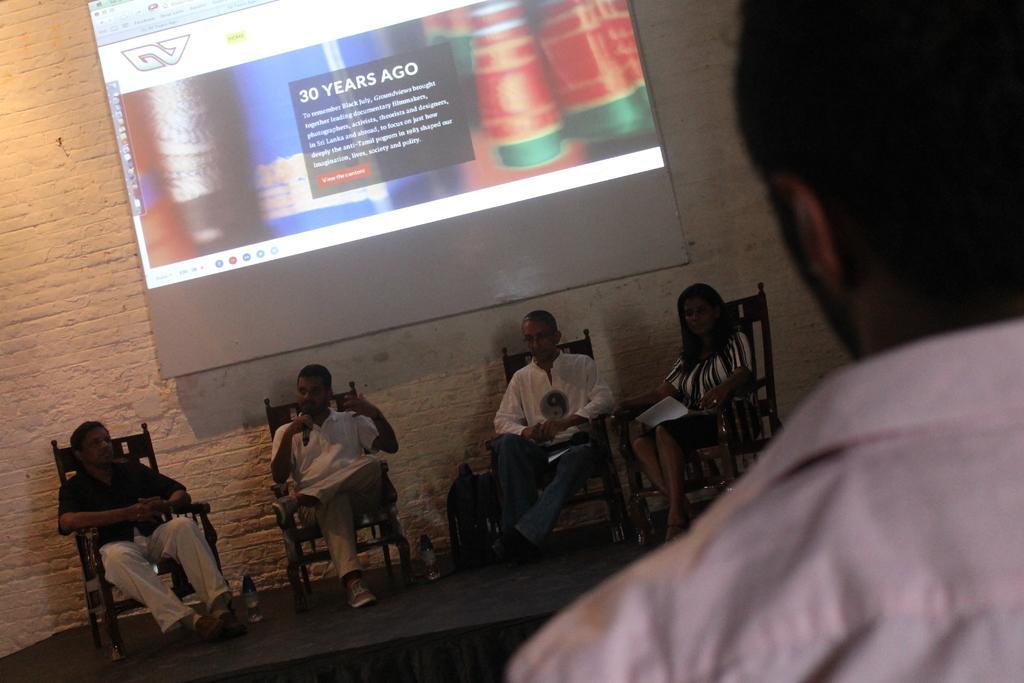Please provide a concise description of this image. In this image we can see people sitting. The man sitting in the center is holding a mic and there are bottles. On the right there is a man. In the background we can see a screen placed on the wall. 